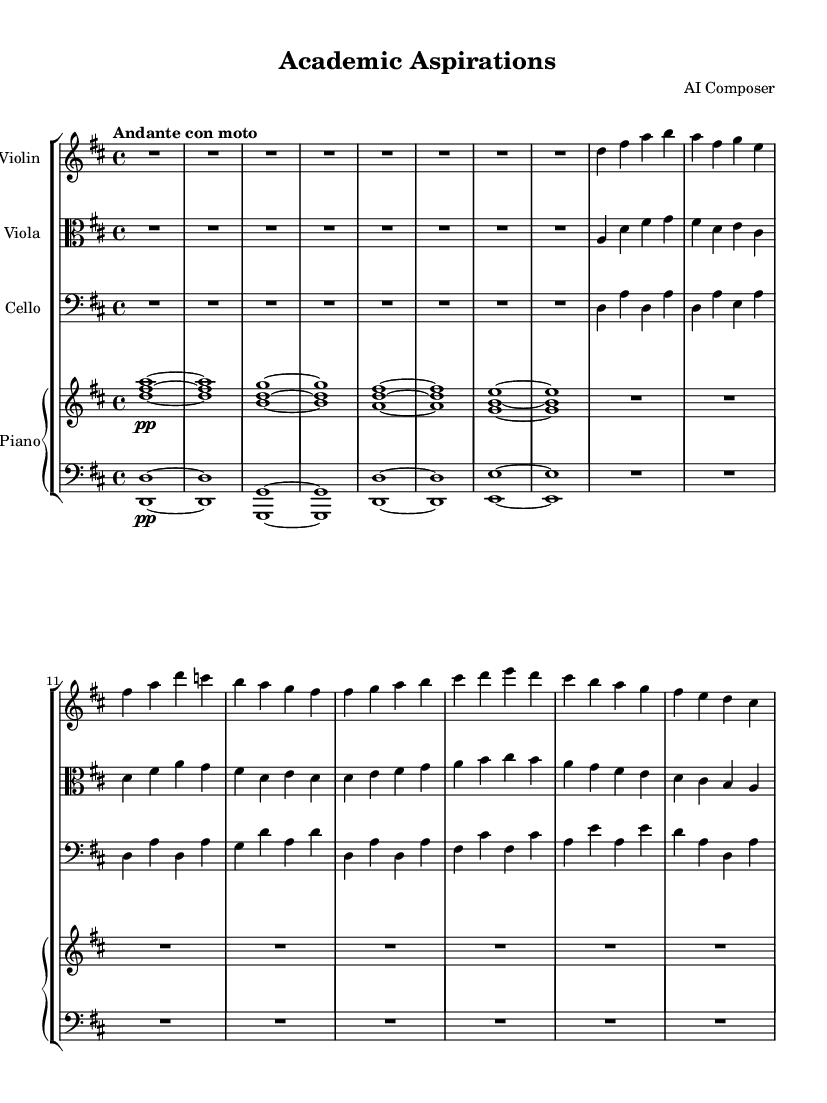What is the key signature of this music? The key signature is indicated at the beginning of the score and shows two sharps, which correspond to F# and C#. This confirms that the piece is in D major.
Answer: D major What is the time signature of this music? The time signature is shown at the beginning of the score as 4/4, which means there are four beats in each measure and the quarter note receives one beat.
Answer: 4/4 What is the tempo marking for this piece? The tempo marking appears at the beginning of the score and indicates "Andante con moto," suggesting a moderately slow tempo with a bit of movement.
Answer: Andante con moto Which instruments are included in this chamber music? The instruments are listed in the score section, where we can see a Violin, Viola, Cello, and Piano. These are typical instruments used in chamber music compositions.
Answer: Violin, Viola, Cello, Piano What can be inferred about the mood of the music based on the tempo and dynamics? The tempo of "Andante con moto" combined with the piano dynamic markings implies a reflective yet emotionally charged mood, suitable for expressing an emotional journey, typical in Romantic music.
Answer: Reflective and emotionally charged How many measures are there in Theme A for the Violin? By counting the measures dedicated to Theme A in the Violin part, we see that there are four measures in total before moving on to Theme B.
Answer: Four measures 